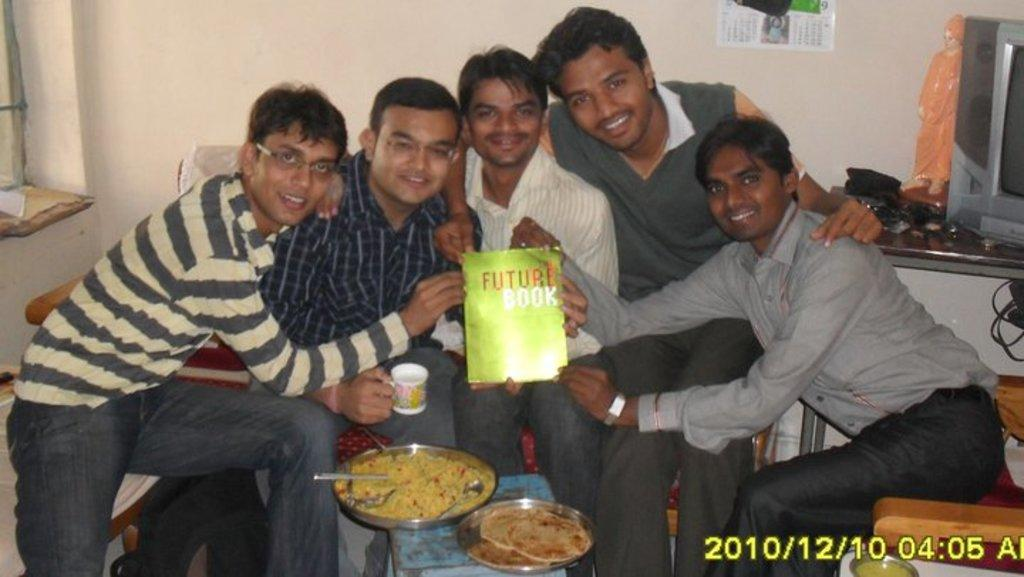How many people are in the image? There are 5 men in the image. What are the men holding in the image? The men are holding a book. Who are the men looking at? The men are looking at someone. What type of objects can be seen on the table in the image? There are 2 plates with food in the image. What type of patch can be seen on the men's clothing in the image? There is no patch visible on the men's clothing in the image. What type of insurance policy do the men have in the image? There is no mention of insurance in the image. 